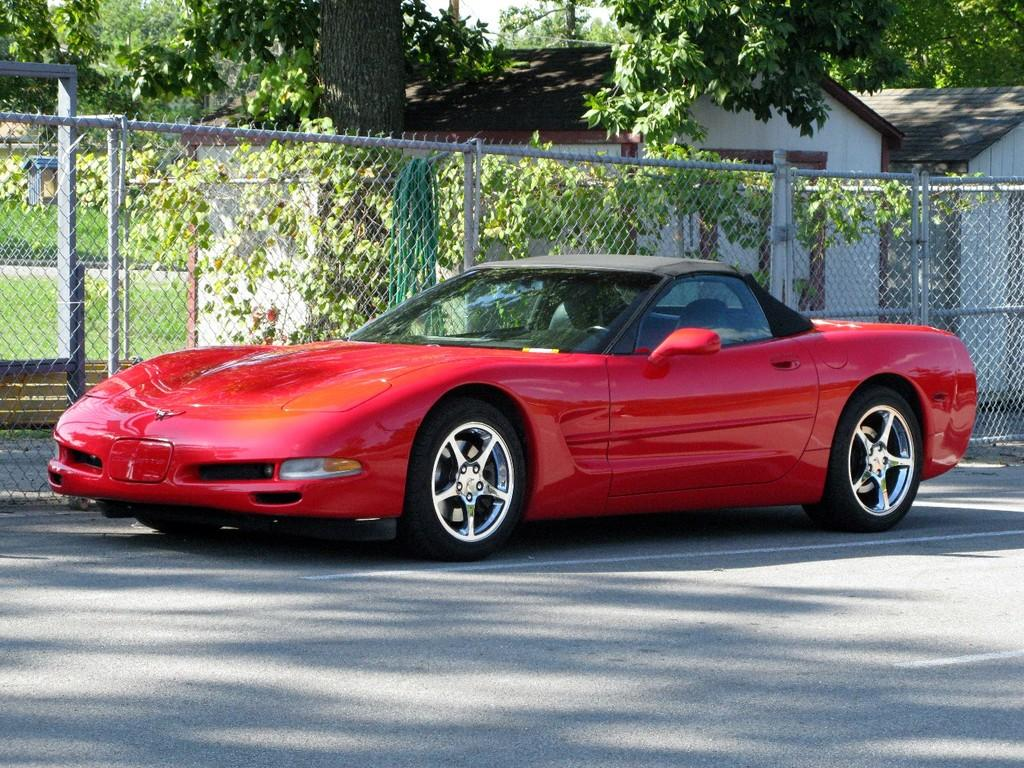What color is the car in the image? The car in the image is red. Where is the car located in the image? The car is on the road in the image. What type of structures can be seen in the image? There are houses visible in the image. What type of barrier is present in the image? There is a metal fence in the image. What type of vegetation is visible in the image? There are trees in the image. How does the car express regret in the image? The car does not express regret in the image, as it is an inanimate object and cannot experience emotions. 